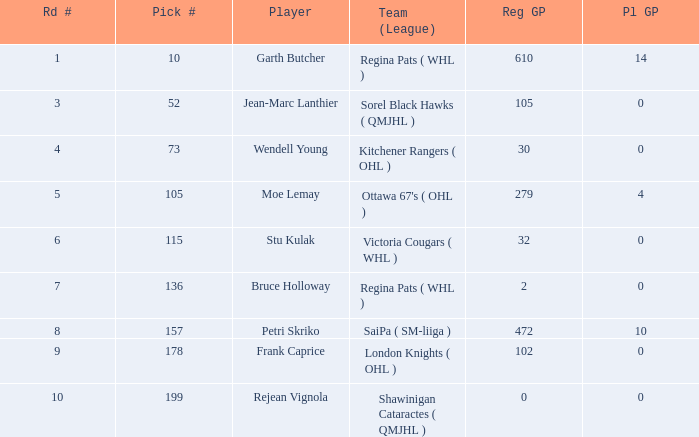What is the average street number when moe lemay is the player? 5.0. 